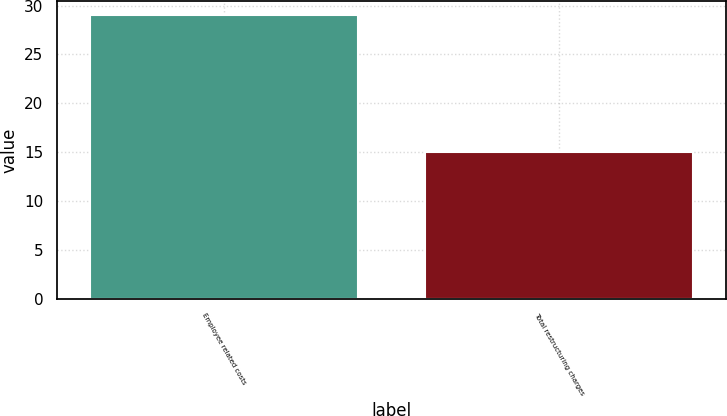Convert chart to OTSL. <chart><loc_0><loc_0><loc_500><loc_500><bar_chart><fcel>Employee related costs<fcel>Total restructuring charges<nl><fcel>29<fcel>15<nl></chart> 